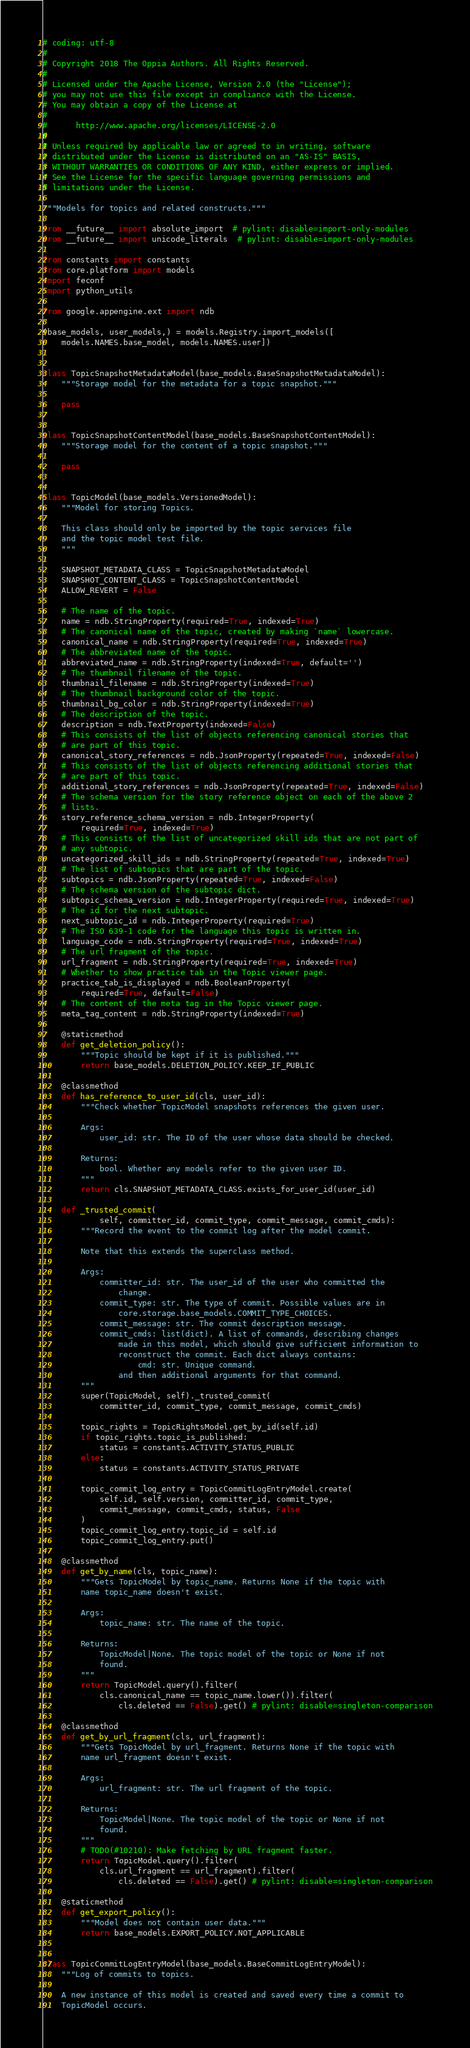Convert code to text. <code><loc_0><loc_0><loc_500><loc_500><_Python_># coding: utf-8
#
# Copyright 2018 The Oppia Authors. All Rights Reserved.
#
# Licensed under the Apache License, Version 2.0 (the "License");
# you may not use this file except in compliance with the License.
# You may obtain a copy of the License at
#
#      http://www.apache.org/licenses/LICENSE-2.0
#
# Unless required by applicable law or agreed to in writing, software
# distributed under the License is distributed on an "AS-IS" BASIS,
# WITHOUT WARRANTIES OR CONDITIONS OF ANY KIND, either express or implied.
# See the License for the specific language governing permissions and
# limitations under the License.

"""Models for topics and related constructs."""

from __future__ import absolute_import  # pylint: disable=import-only-modules
from __future__ import unicode_literals  # pylint: disable=import-only-modules

from constants import constants
from core.platform import models
import feconf
import python_utils

from google.appengine.ext import ndb

(base_models, user_models,) = models.Registry.import_models([
    models.NAMES.base_model, models.NAMES.user])


class TopicSnapshotMetadataModel(base_models.BaseSnapshotMetadataModel):
    """Storage model for the metadata for a topic snapshot."""

    pass


class TopicSnapshotContentModel(base_models.BaseSnapshotContentModel):
    """Storage model for the content of a topic snapshot."""

    pass


class TopicModel(base_models.VersionedModel):
    """Model for storing Topics.

    This class should only be imported by the topic services file
    and the topic model test file.
    """

    SNAPSHOT_METADATA_CLASS = TopicSnapshotMetadataModel
    SNAPSHOT_CONTENT_CLASS = TopicSnapshotContentModel
    ALLOW_REVERT = False

    # The name of the topic.
    name = ndb.StringProperty(required=True, indexed=True)
    # The canonical name of the topic, created by making `name` lowercase.
    canonical_name = ndb.StringProperty(required=True, indexed=True)
    # The abbreviated name of the topic.
    abbreviated_name = ndb.StringProperty(indexed=True, default='')
    # The thumbnail filename of the topic.
    thumbnail_filename = ndb.StringProperty(indexed=True)
    # The thumbnail background color of the topic.
    thumbnail_bg_color = ndb.StringProperty(indexed=True)
    # The description of the topic.
    description = ndb.TextProperty(indexed=False)
    # This consists of the list of objects referencing canonical stories that
    # are part of this topic.
    canonical_story_references = ndb.JsonProperty(repeated=True, indexed=False)
    # This consists of the list of objects referencing additional stories that
    # are part of this topic.
    additional_story_references = ndb.JsonProperty(repeated=True, indexed=False)
    # The schema version for the story reference object on each of the above 2
    # lists.
    story_reference_schema_version = ndb.IntegerProperty(
        required=True, indexed=True)
    # This consists of the list of uncategorized skill ids that are not part of
    # any subtopic.
    uncategorized_skill_ids = ndb.StringProperty(repeated=True, indexed=True)
    # The list of subtopics that are part of the topic.
    subtopics = ndb.JsonProperty(repeated=True, indexed=False)
    # The schema version of the subtopic dict.
    subtopic_schema_version = ndb.IntegerProperty(required=True, indexed=True)
    # The id for the next subtopic.
    next_subtopic_id = ndb.IntegerProperty(required=True)
    # The ISO 639-1 code for the language this topic is written in.
    language_code = ndb.StringProperty(required=True, indexed=True)
    # The url fragment of the topic.
    url_fragment = ndb.StringProperty(required=True, indexed=True)
    # Whether to show practice tab in the Topic viewer page.
    practice_tab_is_displayed = ndb.BooleanProperty(
        required=True, default=False)
    # The content of the meta tag in the Topic viewer page.
    meta_tag_content = ndb.StringProperty(indexed=True)

    @staticmethod
    def get_deletion_policy():
        """Topic should be kept if it is published."""
        return base_models.DELETION_POLICY.KEEP_IF_PUBLIC

    @classmethod
    def has_reference_to_user_id(cls, user_id):
        """Check whether TopicModel snapshots references the given user.

        Args:
            user_id: str. The ID of the user whose data should be checked.

        Returns:
            bool. Whether any models refer to the given user ID.
        """
        return cls.SNAPSHOT_METADATA_CLASS.exists_for_user_id(user_id)

    def _trusted_commit(
            self, committer_id, commit_type, commit_message, commit_cmds):
        """Record the event to the commit log after the model commit.

        Note that this extends the superclass method.

        Args:
            committer_id: str. The user_id of the user who committed the
                change.
            commit_type: str. The type of commit. Possible values are in
                core.storage.base_models.COMMIT_TYPE_CHOICES.
            commit_message: str. The commit description message.
            commit_cmds: list(dict). A list of commands, describing changes
                made in this model, which should give sufficient information to
                reconstruct the commit. Each dict always contains:
                    cmd: str. Unique command.
                and then additional arguments for that command.
        """
        super(TopicModel, self)._trusted_commit(
            committer_id, commit_type, commit_message, commit_cmds)

        topic_rights = TopicRightsModel.get_by_id(self.id)
        if topic_rights.topic_is_published:
            status = constants.ACTIVITY_STATUS_PUBLIC
        else:
            status = constants.ACTIVITY_STATUS_PRIVATE

        topic_commit_log_entry = TopicCommitLogEntryModel.create(
            self.id, self.version, committer_id, commit_type,
            commit_message, commit_cmds, status, False
        )
        topic_commit_log_entry.topic_id = self.id
        topic_commit_log_entry.put()

    @classmethod
    def get_by_name(cls, topic_name):
        """Gets TopicModel by topic_name. Returns None if the topic with
        name topic_name doesn't exist.

        Args:
            topic_name: str. The name of the topic.

        Returns:
            TopicModel|None. The topic model of the topic or None if not
            found.
        """
        return TopicModel.query().filter(
            cls.canonical_name == topic_name.lower()).filter(
                cls.deleted == False).get() # pylint: disable=singleton-comparison

    @classmethod
    def get_by_url_fragment(cls, url_fragment):
        """Gets TopicModel by url_fragment. Returns None if the topic with
        name url_fragment doesn't exist.

        Args:
            url_fragment: str. The url fragment of the topic.

        Returns:
            TopicModel|None. The topic model of the topic or None if not
            found.
        """
        # TODO(#10210): Make fetching by URL fragment faster.
        return TopicModel.query().filter(
            cls.url_fragment == url_fragment).filter(
                cls.deleted == False).get() # pylint: disable=singleton-comparison

    @staticmethod
    def get_export_policy():
        """Model does not contain user data."""
        return base_models.EXPORT_POLICY.NOT_APPLICABLE


class TopicCommitLogEntryModel(base_models.BaseCommitLogEntryModel):
    """Log of commits to topics.

    A new instance of this model is created and saved every time a commit to
    TopicModel occurs.
</code> 